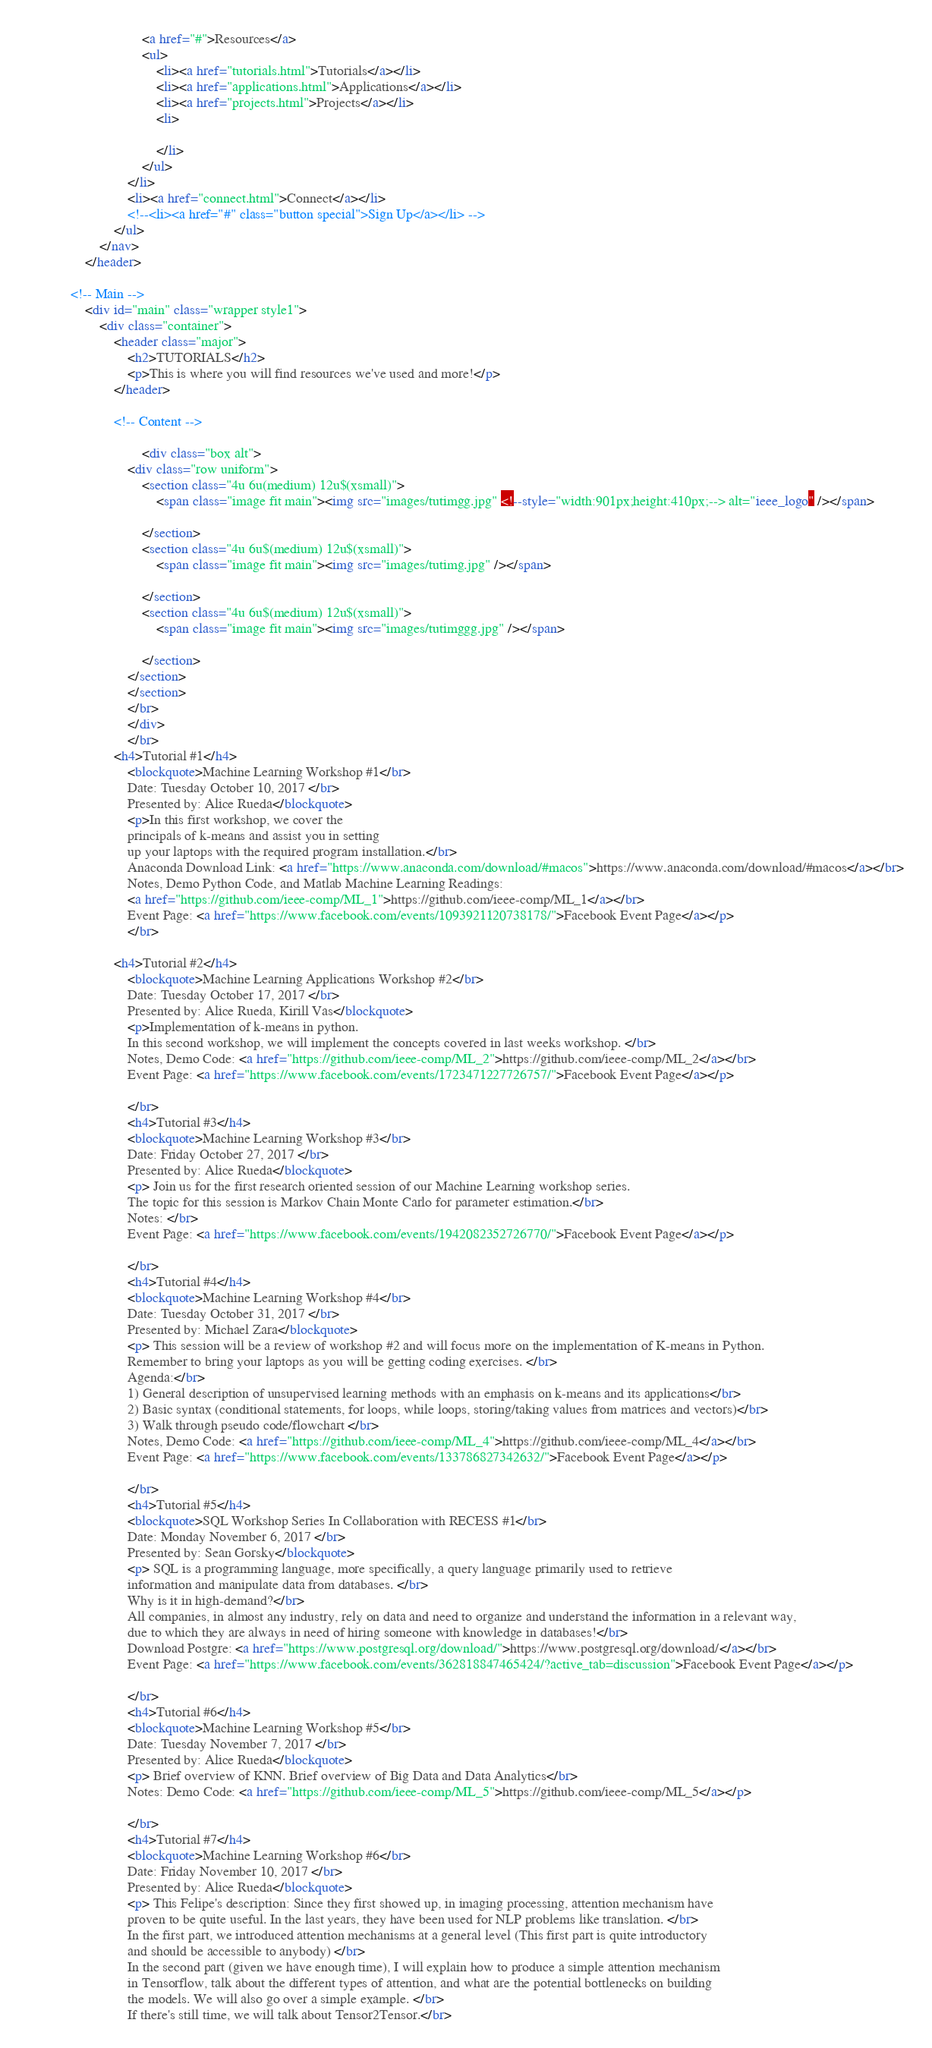Convert code to text. <code><loc_0><loc_0><loc_500><loc_500><_HTML_>								<a href="#">Resources</a>
								<ul>
									<li><a href="tutorials.html">Tutorials</a></li>
									<li><a href="applications.html">Applications</a></li>
									<li><a href="projects.html">Projects</a></li>
									<li>
										
									</li>
								</ul>
							</li>
							<li><a href="connect.html">Connect</a></li>
							<!--<li><a href="#" class="button special">Sign Up</a></li> -->
						</ul>
					</nav>
				</header>

			<!-- Main -->
				<div id="main" class="wrapper style1">
					<div class="container">
						<header class="major">
							<h2>TUTORIALS</h2>
							<p>This is where you will find resources we've used and more!</p>
						</header>

						<!-- Content -->
						
								<div class="box alt">
							<div class="row uniform">
								<section class="4u 6u(medium) 12u$(xsmall)">
									<span class="image fit main"><img src="images/tutimgg.jpg" <!--style="width:901px;height:410px;--> alt="ieee_logo" /></span>
									
								</section>
								<section class="4u 6u$(medium) 12u$(xsmall)">
									<span class="image fit main"><img src="images/tutimg.jpg" /></span>
									
								</section>
								<section class="4u 6u$(medium) 12u$(xsmall)">
									<span class="image fit main"><img src="images/tutimggg.jpg" /></span>
									
								</section>
							</section> 
							</section>
							</br> 
							</div>
							</br>
						<h4>Tutorial #1</h4>
							<blockquote>Machine Learning Workshop #1</br>
							Date: Tuesday October 10, 2017 </br>
							Presented by: Alice Rueda</blockquote>
							<p>In this first workshop, we cover the 
							principals of k-means and assist you in setting 
							up your laptops with the required program installation.</br>
							Anaconda Download Link: <a href="https://www.anaconda.com/download/#macos">https://www.anaconda.com/download/#macos</a></br>
							Notes, Demo Python Code, and Matlab Machine Learning Readings: 
							<a href="https://github.com/ieee-comp/ML_1">https://github.com/ieee-comp/ML_1</a></br>
							Event Page: <a href="https://www.facebook.com/events/1093921120738178/">Facebook Event Page</a></p>
							</br>
							
						<h4>Tutorial #2</h4>
							<blockquote>Machine Learning Applications Workshop #2</br>
							Date: Tuesday October 17, 2017 </br>
							Presented by: Alice Rueda, Kirill Vas</blockquote>
							<p>Implementation of k-means in python. 
							In this second workshop, we will implement the concepts covered in last weeks workshop. </br>
							Notes, Demo Code: <a href="https://github.com/ieee-comp/ML_2">https://github.com/ieee-comp/ML_2</a></br>
							Event Page: <a href="https://www.facebook.com/events/1723471227726757/">Facebook Event Page</a></p>
							
							</br>
							<h4>Tutorial #3</h4>
							<blockquote>Machine Learning Workshop #3</br>
							Date: Friday October 27, 2017 </br>
							Presented by: Alice Rueda</blockquote>
							<p> Join us for the first research oriented session of our Machine Learning workshop series. 
							The topic for this session is Markov Chain Monte Carlo for parameter estimation.</br>
							Notes: </br>
							Event Page: <a href="https://www.facebook.com/events/1942082352726770/">Facebook Event Page</a></p>
							
							</br>
							<h4>Tutorial #4</h4>
							<blockquote>Machine Learning Workshop #4</br>
							Date: Tuesday October 31, 2017 </br>
							Presented by: Michael Zara</blockquote>
							<p> This session will be a review of workshop #2 and will focus more on the implementation of K-means in Python. 
							Remember to bring your laptops as you will be getting coding exercises. </br>
							Agenda:</br>
							1) General description of unsupervised learning methods with an emphasis on k-means and its applications</br>
							2) Basic syntax (conditional statements, for loops, while loops, storing/taking values from matrices and vectors)</br>
							3) Walk through pseudo code/flowchart </br>
							Notes, Demo Code: <a href="https://github.com/ieee-comp/ML_4">https://github.com/ieee-comp/ML_4</a></br>
							Event Page: <a href="https://www.facebook.com/events/133786827342632/">Facebook Event Page</a></p>
							
							</br>
							<h4>Tutorial #5</h4>
							<blockquote>SQL Workshop Series In Collaboration with RECESS #1</br>
							Date: Monday November 6, 2017 </br>
							Presented by: Sean Gorsky</blockquote>
							<p> SQL is a programming language, more specifically, a query language primarily used to retrieve 
							information and manipulate data from databases. </br>
							Why is it in high-demand?</br>
							All companies, in almost any industry, rely on data and need to organize and understand the information in a relevant way, 
							due to which they are always in need of hiring someone with knowledge in databases!</br>
							Download Postgre: <a href="https://www.postgresql.org/download/">https://www.postgresql.org/download/</a></br>
							Event Page: <a href="https://www.facebook.com/events/362818847465424/?active_tab=discussion">Facebook Event Page</a></p>
														
							</br>
							<h4>Tutorial #6</h4>
							<blockquote>Machine Learning Workshop #5</br>
							Date: Tuesday November 7, 2017 </br>
							Presented by: Alice Rueda</blockquote>
							<p> Brief overview of KNN. Brief overview of Big Data and Data Analytics</br>
							Notes: Demo Code: <a href="https://github.com/ieee-comp/ML_5">https://github.com/ieee-comp/ML_5</a></p>
							
							</br>
							<h4>Tutorial #7</h4>
							<blockquote>Machine Learning Workshop #6</br>
							Date: Friday November 10, 2017 </br>
							Presented by: Alice Rueda</blockquote>
							<p> This Felipe's description: Since they first showed up, in imaging processing, attention mechanism have 
							proven to be quite useful. In the last years, they have been used for NLP problems like translation. </br>
							In the first part, we introduced attention mechanisms at a general level (This first part is quite introductory 
							and should be accessible to anybody) </br>
							In the second part (given we have enough time), I will explain how to produce a simple attention mechanism 
							in Tensorflow, talk about the different types of attention, and what are the potential bottlenecks on building 
							the models. We will also go over a simple example. </br>
							If there's still time, we will talk about Tensor2Tensor.</br></code> 